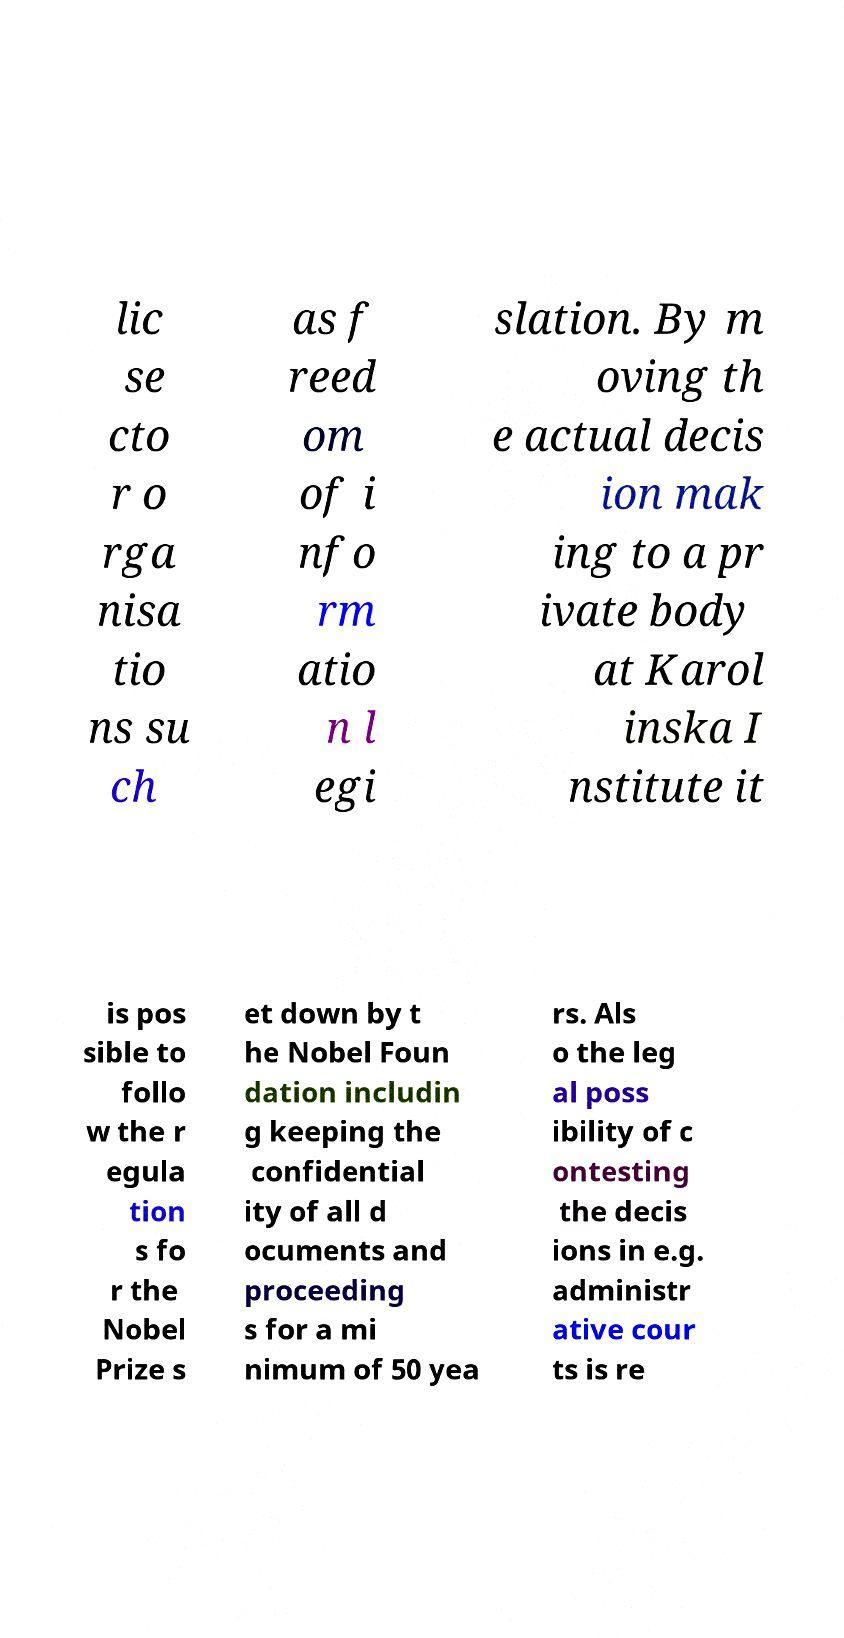There's text embedded in this image that I need extracted. Can you transcribe it verbatim? lic se cto r o rga nisa tio ns su ch as f reed om of i nfo rm atio n l egi slation. By m oving th e actual decis ion mak ing to a pr ivate body at Karol inska I nstitute it is pos sible to follo w the r egula tion s fo r the Nobel Prize s et down by t he Nobel Foun dation includin g keeping the confidential ity of all d ocuments and proceeding s for a mi nimum of 50 yea rs. Als o the leg al poss ibility of c ontesting the decis ions in e.g. administr ative cour ts is re 